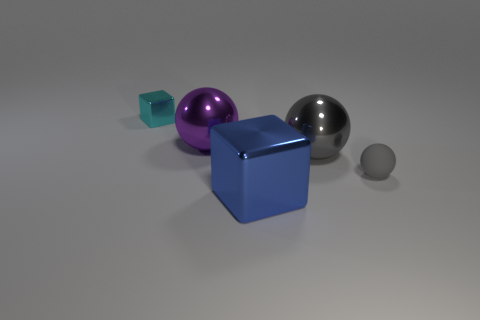Add 5 purple metal spheres. How many objects exist? 10 Subtract all balls. How many objects are left? 2 Subtract all gray matte cubes. Subtract all rubber spheres. How many objects are left? 4 Add 1 small shiny blocks. How many small shiny blocks are left? 2 Add 4 metal cubes. How many metal cubes exist? 6 Subtract 0 yellow balls. How many objects are left? 5 